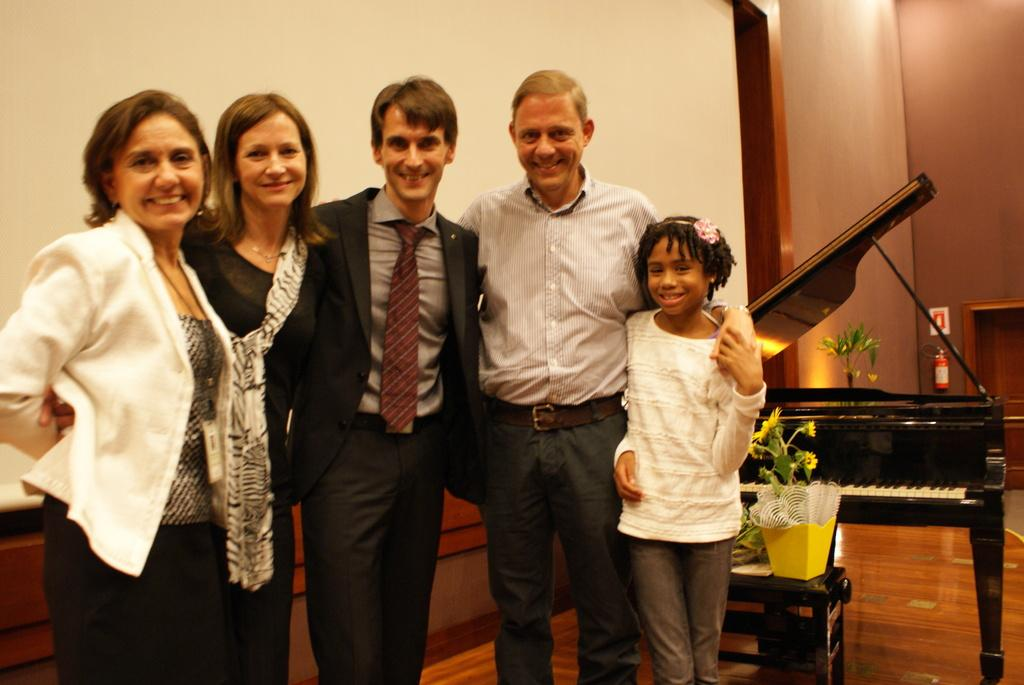How many people are in the image? There is a group of people in the image. What are the people doing in the image? The people are standing on the floor and smiling. What can be seen in the background of the image? There is a wall in the background of the image. What objects are present in the image besides the people? There is a flower pot on a table and a piano in the image. What type of plate is being used as a cushion for the piano in the image? There is no plate or cushion present for the piano in the image; it is a piano without any additional items. 